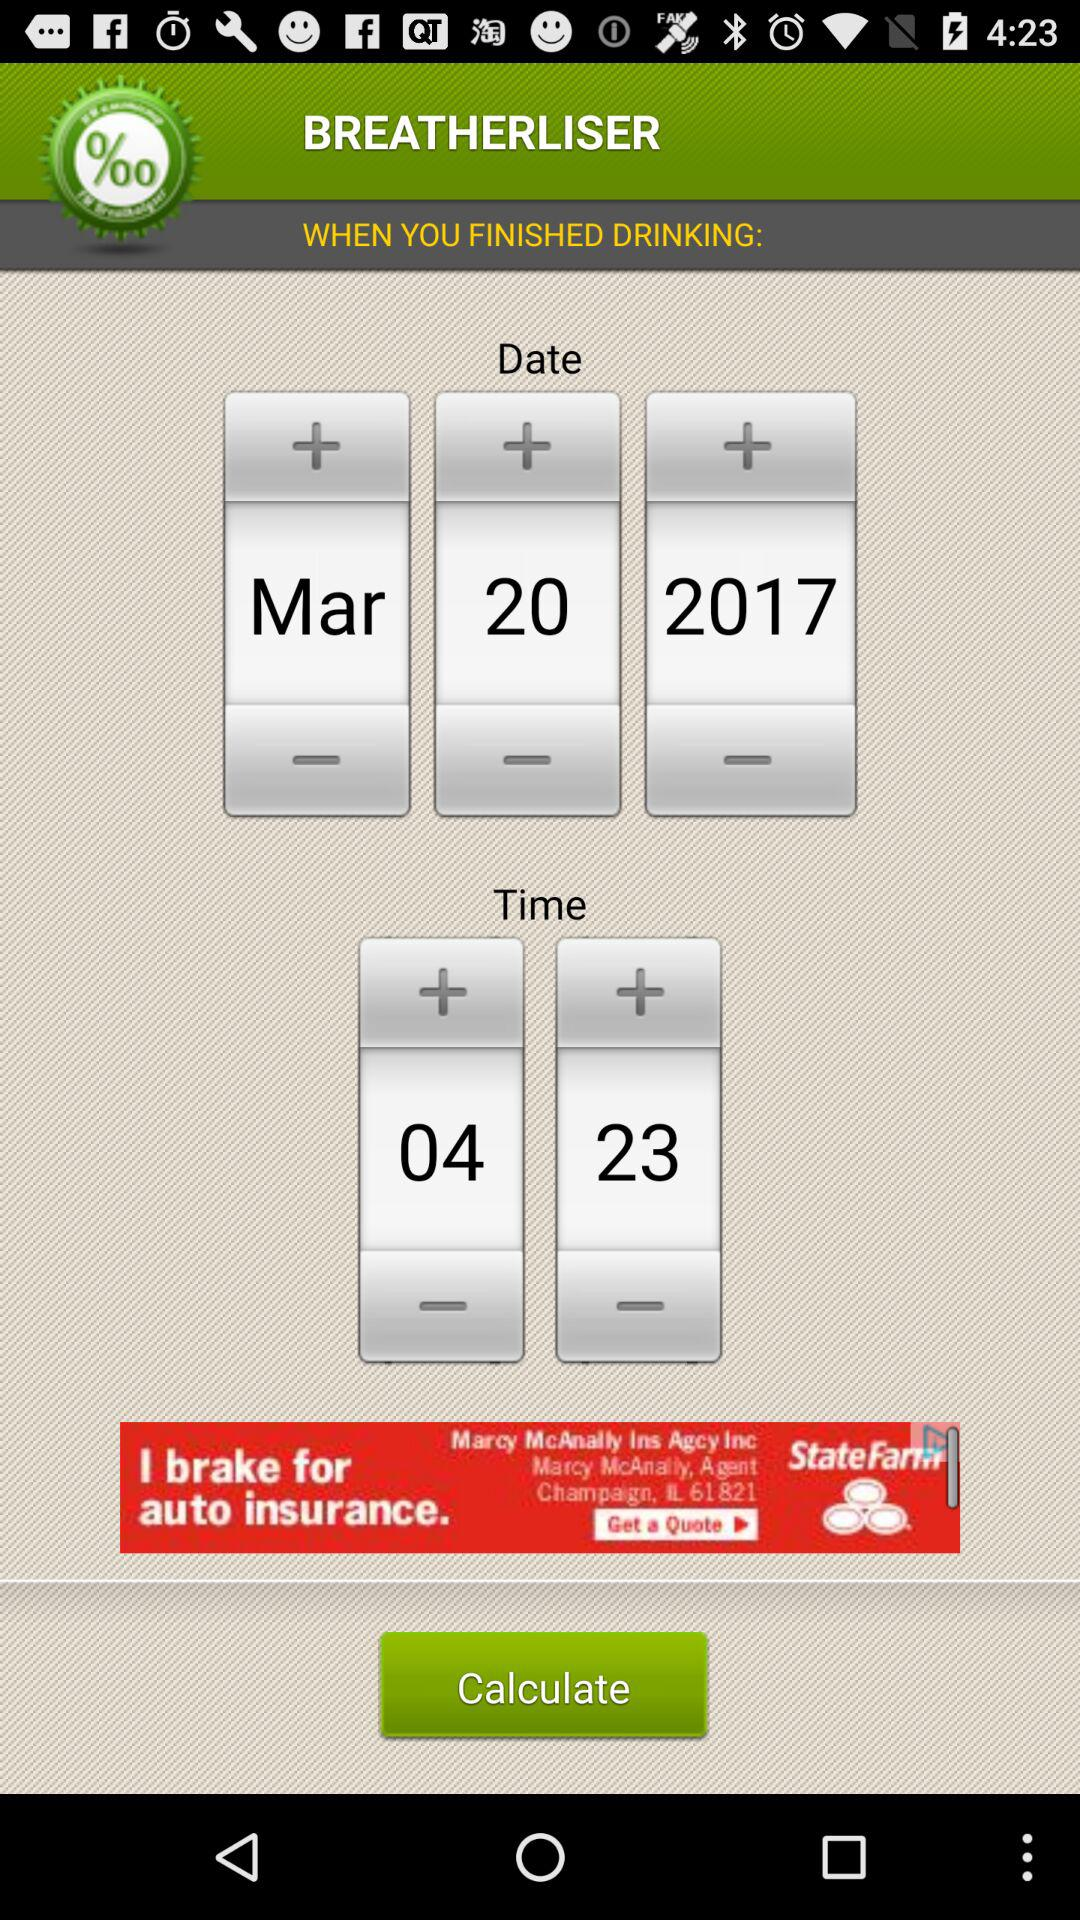What is the selected time? The selected time is 04:23. 